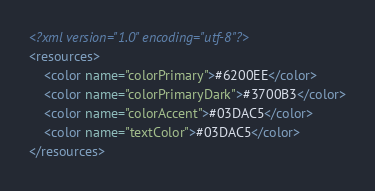Convert code to text. <code><loc_0><loc_0><loc_500><loc_500><_XML_><?xml version="1.0" encoding="utf-8"?>
<resources>
    <color name="colorPrimary">#6200EE</color>
    <color name="colorPrimaryDark">#3700B3</color>
    <color name="colorAccent">#03DAC5</color>
    <color name="textColor">#03DAC5</color>
</resources>
</code> 